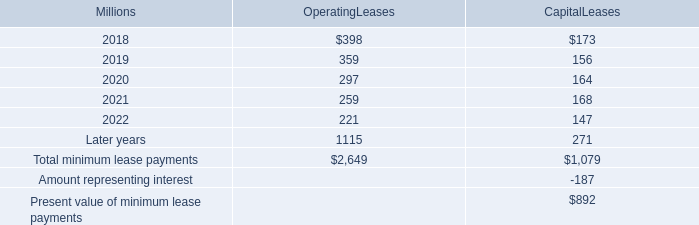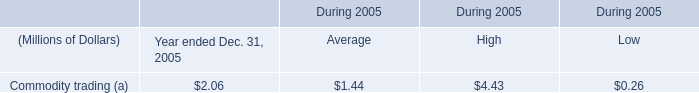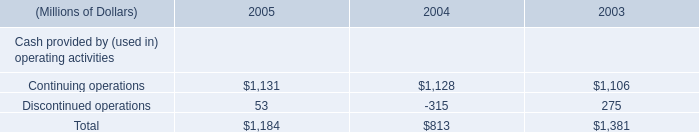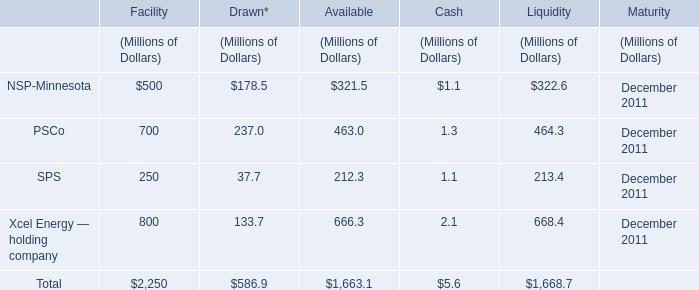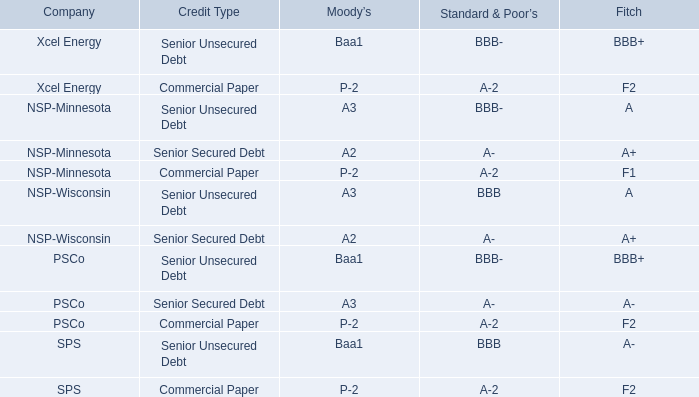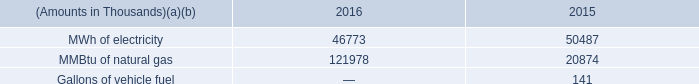what percentage of total minimum lease payments are capital leases? 
Computations: (1079 / (2649 + 1079))
Answer: 0.28943. 